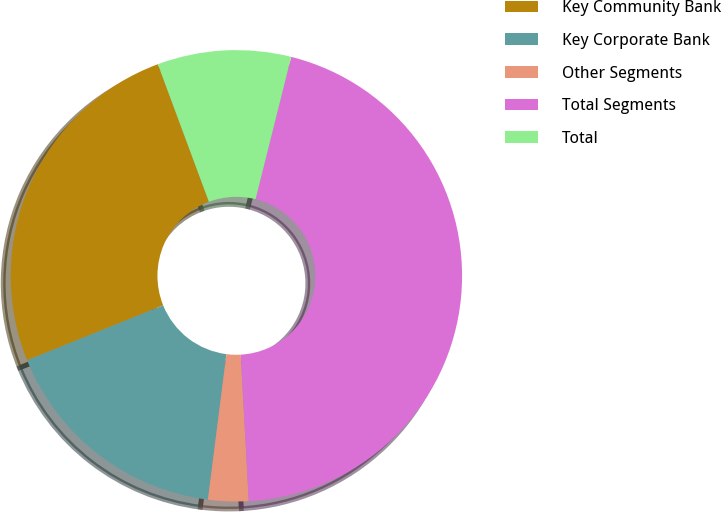<chart> <loc_0><loc_0><loc_500><loc_500><pie_chart><fcel>Key Community Bank<fcel>Key Corporate Bank<fcel>Other Segments<fcel>Total Segments<fcel>Total<nl><fcel>25.45%<fcel>16.88%<fcel>2.89%<fcel>45.22%<fcel>9.56%<nl></chart> 